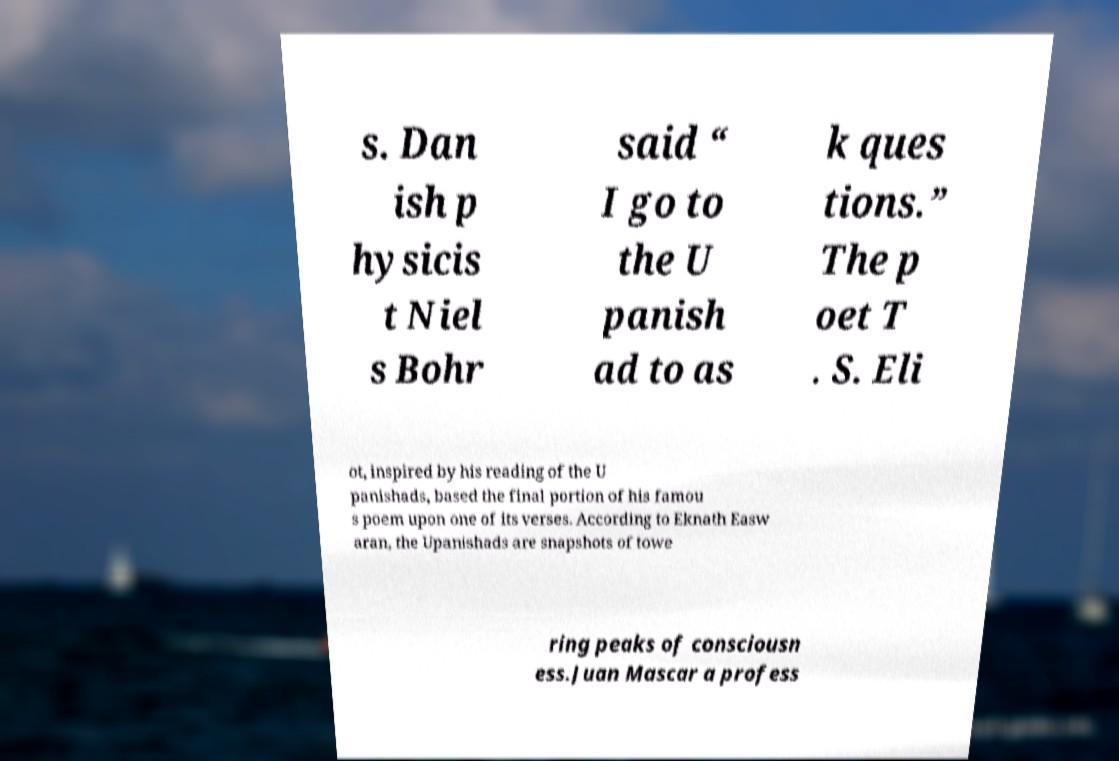There's text embedded in this image that I need extracted. Can you transcribe it verbatim? s. Dan ish p hysicis t Niel s Bohr said “ I go to the U panish ad to as k ques tions.” The p oet T . S. Eli ot, inspired by his reading of the U panishads, based the final portion of his famou s poem upon one of its verses. According to Eknath Easw aran, the Upanishads are snapshots of towe ring peaks of consciousn ess.Juan Mascar a profess 